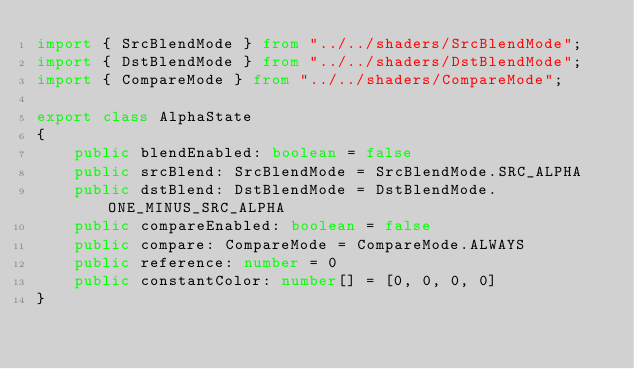<code> <loc_0><loc_0><loc_500><loc_500><_TypeScript_>import { SrcBlendMode } from "../../shaders/SrcBlendMode";
import { DstBlendMode } from "../../shaders/DstBlendMode";
import { CompareMode } from "../../shaders/CompareMode";

export class AlphaState
{
    public blendEnabled: boolean = false
    public srcBlend: SrcBlendMode = SrcBlendMode.SRC_ALPHA
    public dstBlend: DstBlendMode = DstBlendMode.ONE_MINUS_SRC_ALPHA
    public compareEnabled: boolean = false
    public compare: CompareMode = CompareMode.ALWAYS
    public reference: number = 0
    public constantColor: number[] = [0, 0, 0, 0]
}</code> 